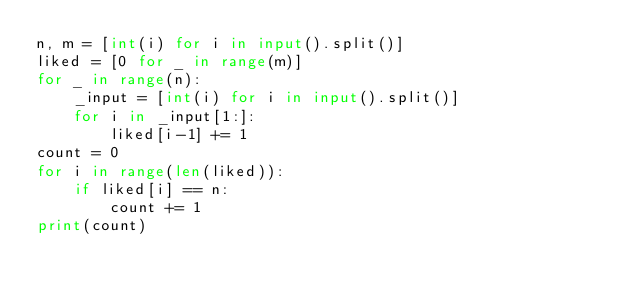Convert code to text. <code><loc_0><loc_0><loc_500><loc_500><_Python_>n, m = [int(i) for i in input().split()]
liked = [0 for _ in range(m)]
for _ in range(n):
    _input = [int(i) for i in input().split()]
    for i in _input[1:]:
        liked[i-1] += 1
count = 0
for i in range(len(liked)):
    if liked[i] == n:
        count += 1
print(count)</code> 